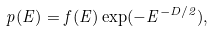Convert formula to latex. <formula><loc_0><loc_0><loc_500><loc_500>p ( E ) = f ( E ) \exp ( - E ^ { - D / 2 } ) ,</formula> 